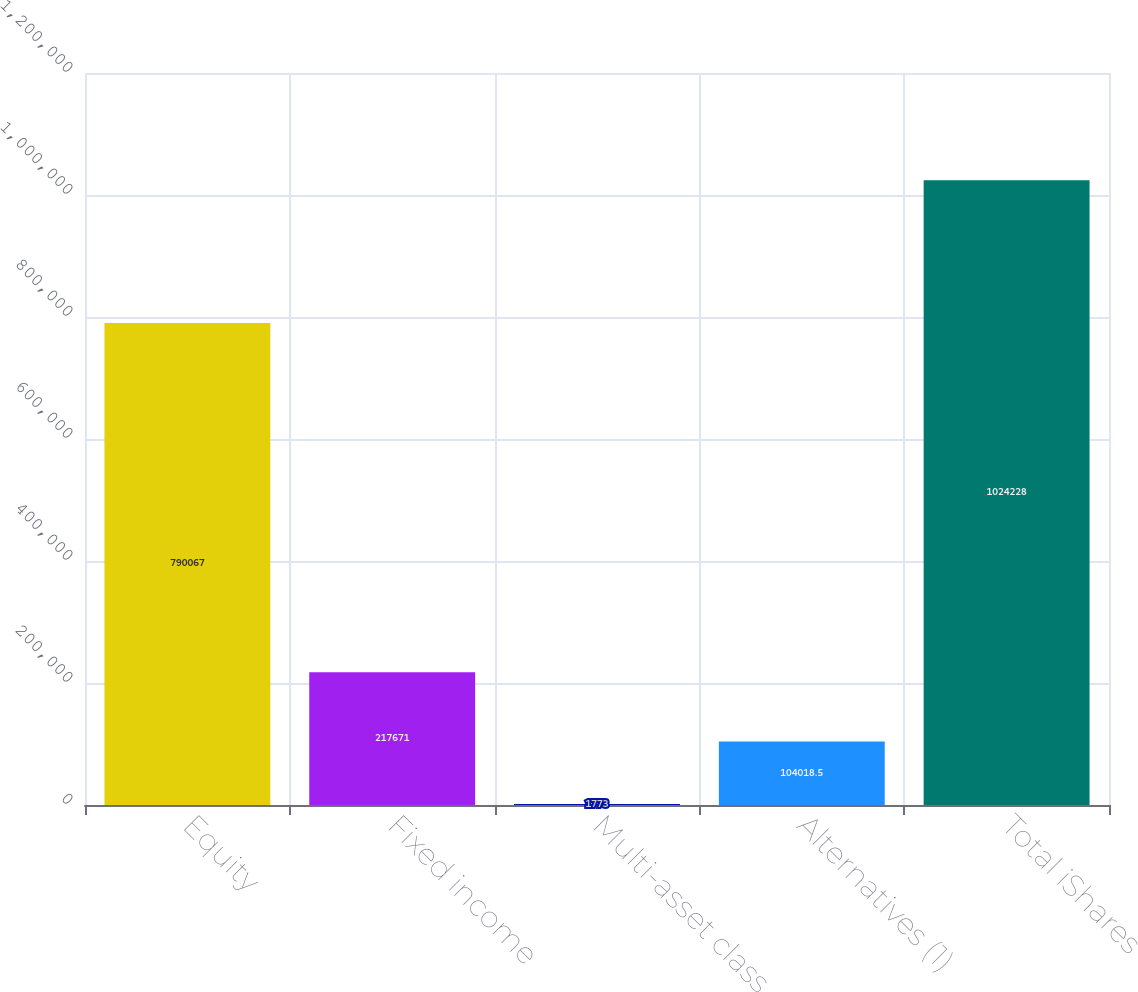<chart> <loc_0><loc_0><loc_500><loc_500><bar_chart><fcel>Equity<fcel>Fixed income<fcel>Multi-asset class<fcel>Alternatives (1)<fcel>Total iShares<nl><fcel>790067<fcel>217671<fcel>1773<fcel>104018<fcel>1.02423e+06<nl></chart> 